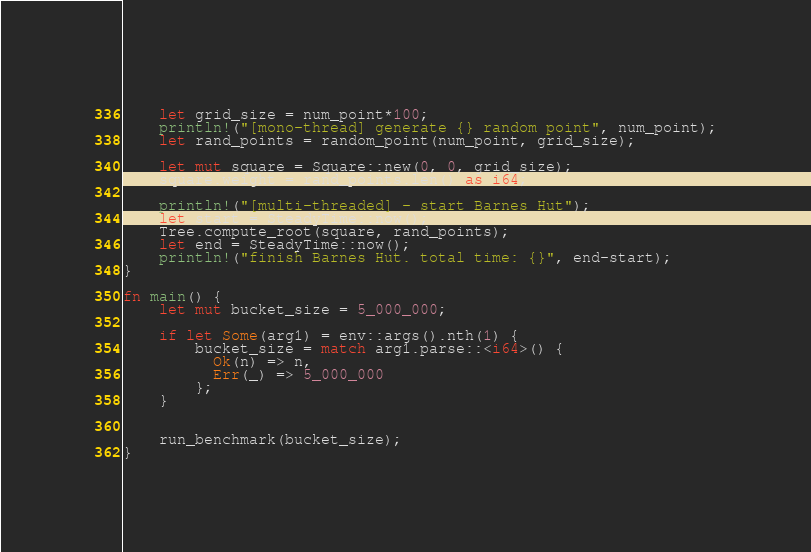<code> <loc_0><loc_0><loc_500><loc_500><_Rust_>	
	let grid_size = num_point*100;
	println!("[mono-thread] generate {} random point", num_point);
	let rand_points = random_point(num_point, grid_size);
	
	let mut square = Square::new(0, 0, grid_size);
	square.weight = rand_points.len() as i64;
	
	println!("[multi-threaded] - start Barnes Hut");
	let start = SteadyTime::now();
	Tree.compute_root(square, rand_points);
	let end = SteadyTime::now();
	println!("finish Barnes Hut. total time: {}", end-start);
}

fn main() {
	let mut bucket_size = 5_000_000;
	
	if let Some(arg1) = env::args().nth(1) {
		bucket_size = match arg1.parse::<i64>() {
		  Ok(n) => n,
		  Err(_) => 5_000_000
		};
	}

	
	run_benchmark(bucket_size);
}</code> 